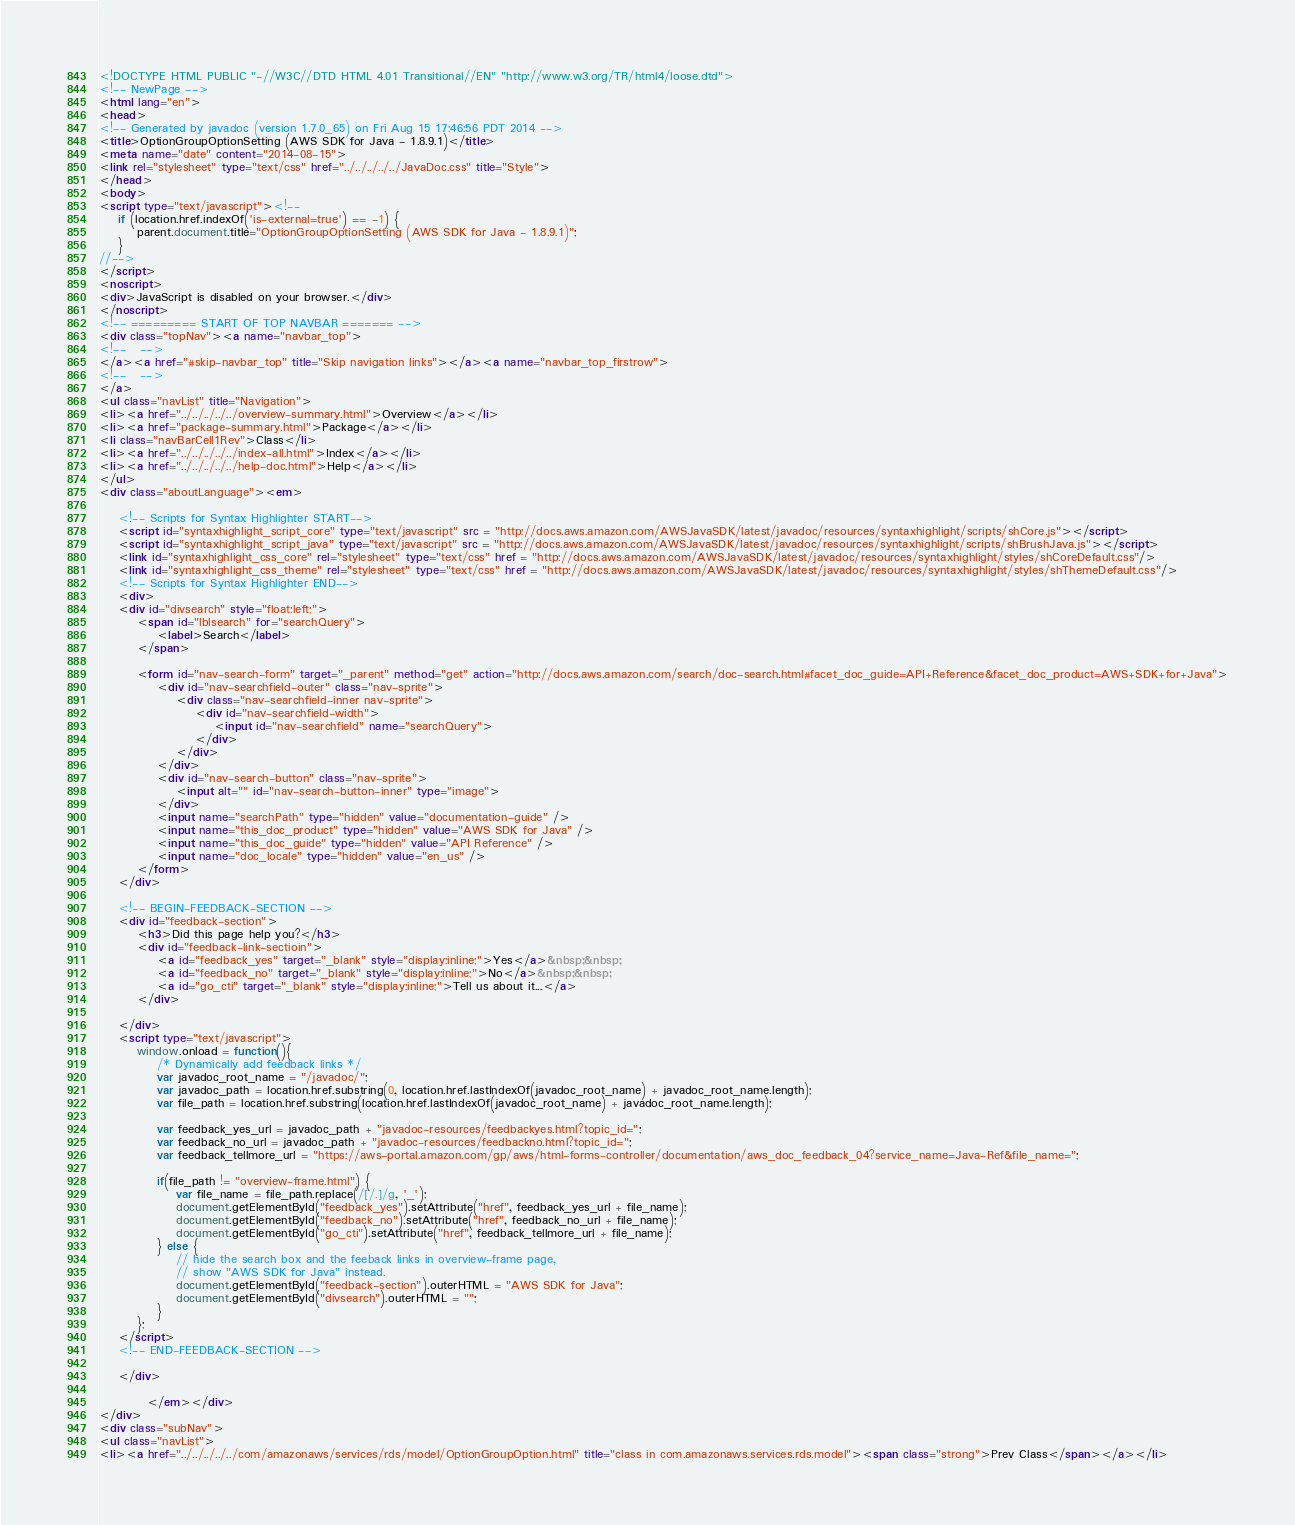<code> <loc_0><loc_0><loc_500><loc_500><_HTML_><!DOCTYPE HTML PUBLIC "-//W3C//DTD HTML 4.01 Transitional//EN" "http://www.w3.org/TR/html4/loose.dtd">
<!-- NewPage -->
<html lang="en">
<head>
<!-- Generated by javadoc (version 1.7.0_65) on Fri Aug 15 17:46:56 PDT 2014 -->
<title>OptionGroupOptionSetting (AWS SDK for Java - 1.8.9.1)</title>
<meta name="date" content="2014-08-15">
<link rel="stylesheet" type="text/css" href="../../../../../JavaDoc.css" title="Style">
</head>
<body>
<script type="text/javascript"><!--
    if (location.href.indexOf('is-external=true') == -1) {
        parent.document.title="OptionGroupOptionSetting (AWS SDK for Java - 1.8.9.1)";
    }
//-->
</script>
<noscript>
<div>JavaScript is disabled on your browser.</div>
</noscript>
<!-- ========= START OF TOP NAVBAR ======= -->
<div class="topNav"><a name="navbar_top">
<!--   -->
</a><a href="#skip-navbar_top" title="Skip navigation links"></a><a name="navbar_top_firstrow">
<!--   -->
</a>
<ul class="navList" title="Navigation">
<li><a href="../../../../../overview-summary.html">Overview</a></li>
<li><a href="package-summary.html">Package</a></li>
<li class="navBarCell1Rev">Class</li>
<li><a href="../../../../../index-all.html">Index</a></li>
<li><a href="../../../../../help-doc.html">Help</a></li>
</ul>
<div class="aboutLanguage"><em>

    <!-- Scripts for Syntax Highlighter START-->
    <script id="syntaxhighlight_script_core" type="text/javascript" src = "http://docs.aws.amazon.com/AWSJavaSDK/latest/javadoc/resources/syntaxhighlight/scripts/shCore.js"></script>
    <script id="syntaxhighlight_script_java" type="text/javascript" src = "http://docs.aws.amazon.com/AWSJavaSDK/latest/javadoc/resources/syntaxhighlight/scripts/shBrushJava.js"></script>
    <link id="syntaxhighlight_css_core" rel="stylesheet" type="text/css" href = "http://docs.aws.amazon.com/AWSJavaSDK/latest/javadoc/resources/syntaxhighlight/styles/shCoreDefault.css"/>
    <link id="syntaxhighlight_css_theme" rel="stylesheet" type="text/css" href = "http://docs.aws.amazon.com/AWSJavaSDK/latest/javadoc/resources/syntaxhighlight/styles/shThemeDefault.css"/>
    <!-- Scripts for Syntax Highlighter END-->
    <div>
    <div id="divsearch" style="float:left;">
        <span id="lblsearch" for="searchQuery">
            <label>Search</label>
        </span>

        <form id="nav-search-form" target="_parent" method="get" action="http://docs.aws.amazon.com/search/doc-search.html#facet_doc_guide=API+Reference&facet_doc_product=AWS+SDK+for+Java">
            <div id="nav-searchfield-outer" class="nav-sprite">
                <div class="nav-searchfield-inner nav-sprite">
                    <div id="nav-searchfield-width">
                        <input id="nav-searchfield" name="searchQuery">
                    </div>
                </div>
            </div>
            <div id="nav-search-button" class="nav-sprite">
                <input alt="" id="nav-search-button-inner" type="image">
            </div>
            <input name="searchPath" type="hidden" value="documentation-guide" />
            <input name="this_doc_product" type="hidden" value="AWS SDK for Java" />
            <input name="this_doc_guide" type="hidden" value="API Reference" />
            <input name="doc_locale" type="hidden" value="en_us" />
        </form>
    </div>

    <!-- BEGIN-FEEDBACK-SECTION -->
    <div id="feedback-section">
        <h3>Did this page help you?</h3>
        <div id="feedback-link-sectioin">
            <a id="feedback_yes" target="_blank" style="display:inline;">Yes</a>&nbsp;&nbsp;
            <a id="feedback_no" target="_blank" style="display:inline;">No</a>&nbsp;&nbsp;
            <a id="go_cti" target="_blank" style="display:inline;">Tell us about it...</a>
        </div>

    </div>
    <script type="text/javascript">
        window.onload = function(){
            /* Dynamically add feedback links */
            var javadoc_root_name = "/javadoc/";
            var javadoc_path = location.href.substring(0, location.href.lastIndexOf(javadoc_root_name) + javadoc_root_name.length);
            var file_path = location.href.substring(location.href.lastIndexOf(javadoc_root_name) + javadoc_root_name.length);

            var feedback_yes_url = javadoc_path + "javadoc-resources/feedbackyes.html?topic_id=";
            var feedback_no_url = javadoc_path + "javadoc-resources/feedbackno.html?topic_id=";
            var feedback_tellmore_url = "https://aws-portal.amazon.com/gp/aws/html-forms-controller/documentation/aws_doc_feedback_04?service_name=Java-Ref&file_name=";

            if(file_path != "overview-frame.html") {
                var file_name = file_path.replace(/[/.]/g, '_');
                document.getElementById("feedback_yes").setAttribute("href", feedback_yes_url + file_name);
                document.getElementById("feedback_no").setAttribute("href", feedback_no_url + file_name);
                document.getElementById("go_cti").setAttribute("href", feedback_tellmore_url + file_name);
            } else {
                // hide the search box and the feeback links in overview-frame page,
                // show "AWS SDK for Java" instead.
                document.getElementById("feedback-section").outerHTML = "AWS SDK for Java";
                document.getElementById("divsearch").outerHTML = "";
            }
        };
    </script>
    <!-- END-FEEDBACK-SECTION -->

    </div>

          </em></div>
</div>
<div class="subNav">
<ul class="navList">
<li><a href="../../../../../com/amazonaws/services/rds/model/OptionGroupOption.html" title="class in com.amazonaws.services.rds.model"><span class="strong">Prev Class</span></a></li></code> 